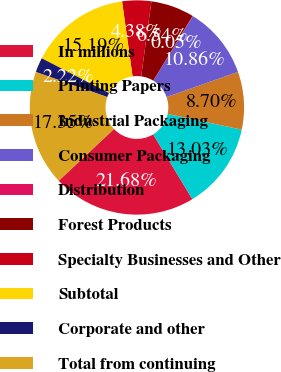<chart> <loc_0><loc_0><loc_500><loc_500><pie_chart><fcel>In millions<fcel>Printing Papers<fcel>Industrial Packaging<fcel>Consumer Packaging<fcel>Distribution<fcel>Forest Products<fcel>Specialty Businesses and Other<fcel>Subtotal<fcel>Corporate and other<fcel>Total from continuing<nl><fcel>21.68%<fcel>13.03%<fcel>8.7%<fcel>10.86%<fcel>0.05%<fcel>6.54%<fcel>4.38%<fcel>15.19%<fcel>2.22%<fcel>17.35%<nl></chart> 